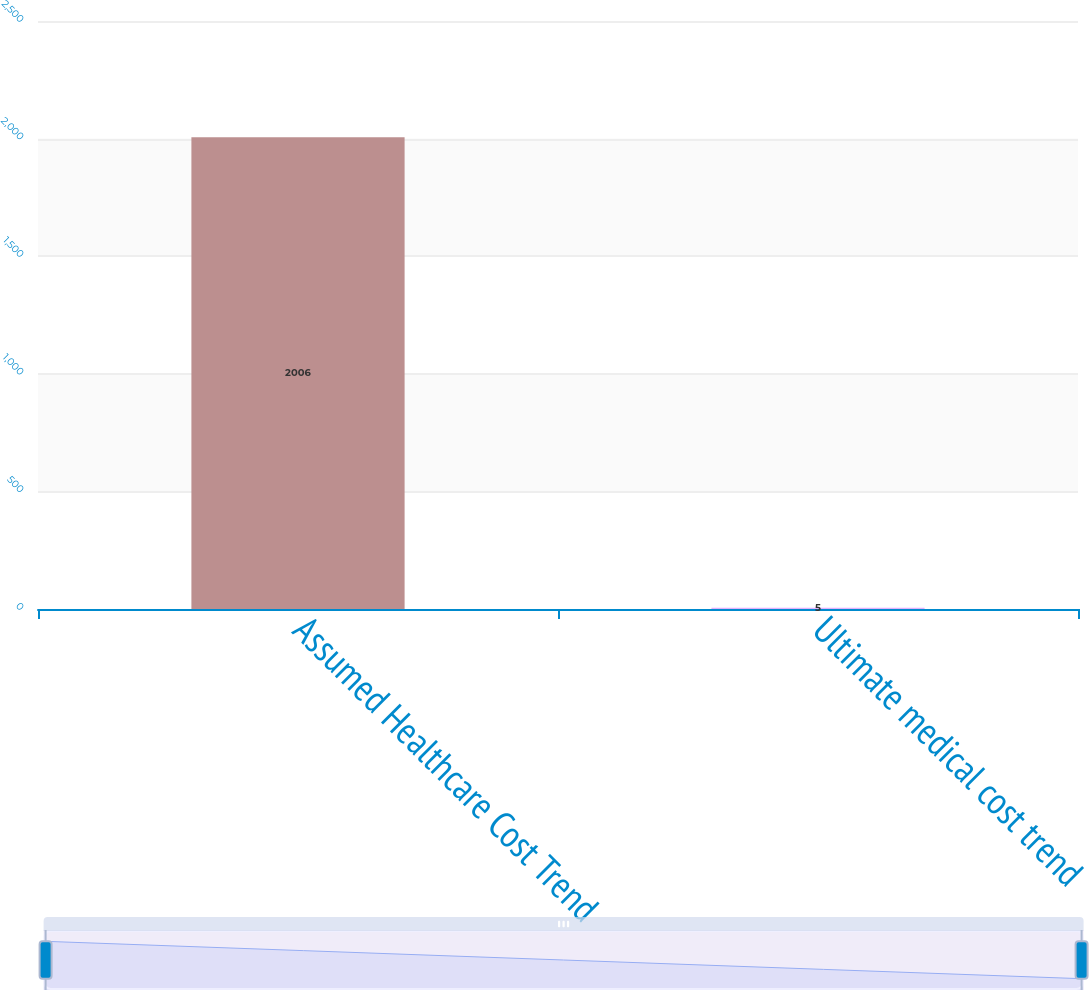Convert chart to OTSL. <chart><loc_0><loc_0><loc_500><loc_500><bar_chart><fcel>Assumed Healthcare Cost Trend<fcel>Ultimate medical cost trend<nl><fcel>2006<fcel>5<nl></chart> 